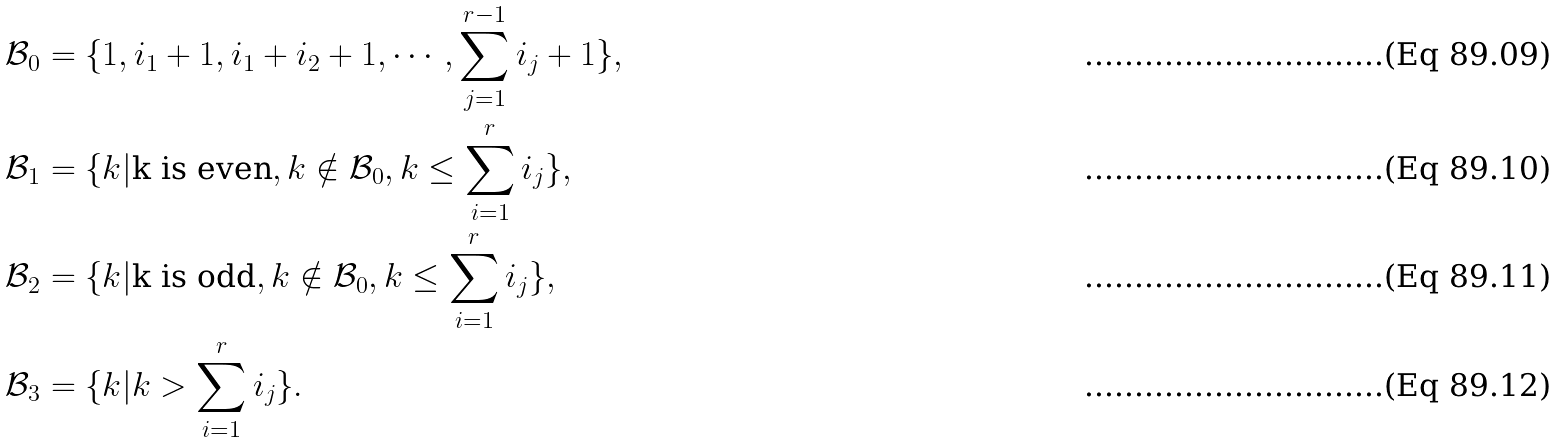Convert formula to latex. <formula><loc_0><loc_0><loc_500><loc_500>& \mathcal { B } _ { 0 } = \{ 1 , i _ { 1 } + 1 , i _ { 1 } + i _ { 2 } + 1 , \cdots , \sum _ { j = 1 } ^ { r - 1 } i _ { j } + 1 \} , \\ & \mathcal { B } _ { 1 } = \{ k | \text {k is even} , k \notin \mathcal { B } _ { 0 } , k \leq \sum _ { i = 1 } ^ { r } i _ { j } \} , \\ & \mathcal { B } _ { 2 } = \{ k | \text {k is odd} , k \notin \mathcal { B } _ { 0 } , k \leq \sum _ { i = 1 } ^ { r } i _ { j } \} , \\ & \mathcal { B } _ { 3 } = \{ k | k > \sum _ { i = 1 } ^ { r } i _ { j } \} .</formula> 